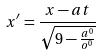Convert formula to latex. <formula><loc_0><loc_0><loc_500><loc_500>x ^ { \prime } = \frac { x - a t } { \sqrt { 9 - \frac { a ^ { 0 } } { o ^ { 0 } } } }</formula> 